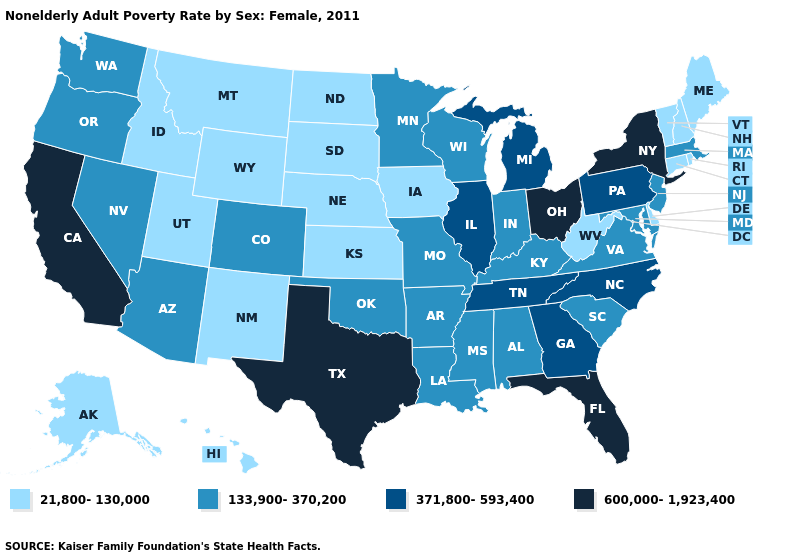Does Michigan have a higher value than Tennessee?
Keep it brief. No. Does Ohio have the highest value in the USA?
Keep it brief. Yes. Does California have the same value as Kansas?
Keep it brief. No. Does Connecticut have the highest value in the USA?
Concise answer only. No. Does the map have missing data?
Be succinct. No. What is the value of Kansas?
Keep it brief. 21,800-130,000. What is the value of Nebraska?
Concise answer only. 21,800-130,000. What is the value of Florida?
Be succinct. 600,000-1,923,400. What is the lowest value in the USA?
Keep it brief. 21,800-130,000. Name the states that have a value in the range 21,800-130,000?
Quick response, please. Alaska, Connecticut, Delaware, Hawaii, Idaho, Iowa, Kansas, Maine, Montana, Nebraska, New Hampshire, New Mexico, North Dakota, Rhode Island, South Dakota, Utah, Vermont, West Virginia, Wyoming. Which states hav the highest value in the MidWest?
Write a very short answer. Ohio. Does Louisiana have the highest value in the South?
Write a very short answer. No. Which states have the highest value in the USA?
Quick response, please. California, Florida, New York, Ohio, Texas. Does Alaska have the lowest value in the USA?
Answer briefly. Yes. 